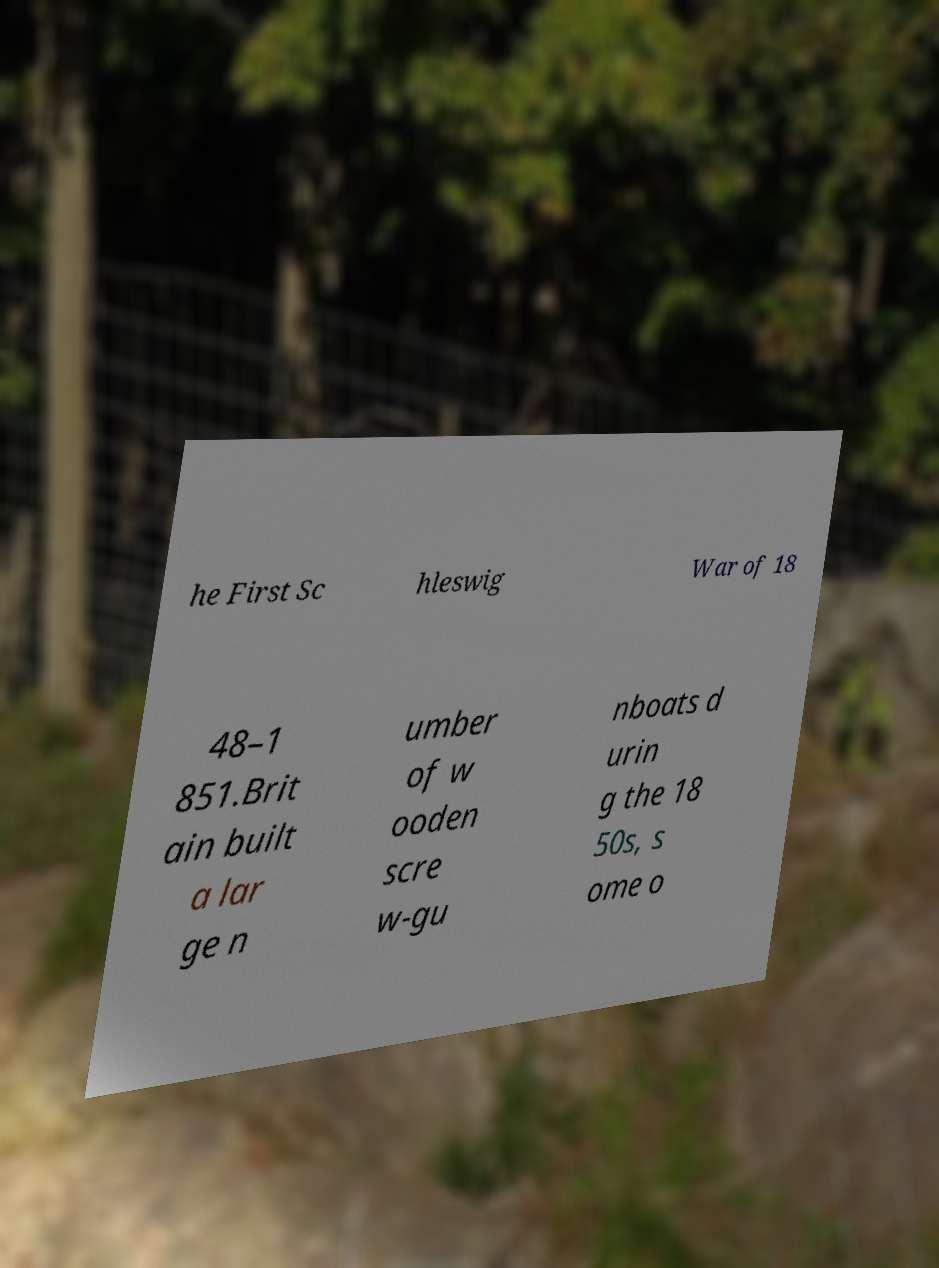I need the written content from this picture converted into text. Can you do that? he First Sc hleswig War of 18 48–1 851.Brit ain built a lar ge n umber of w ooden scre w-gu nboats d urin g the 18 50s, s ome o 